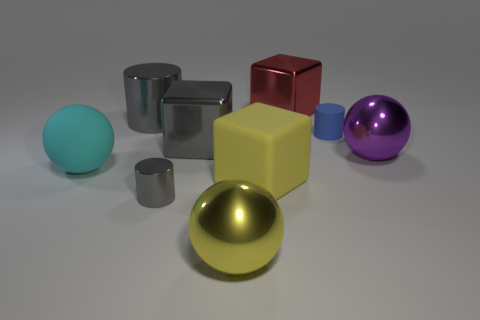Subtract all large gray metal cubes. How many cubes are left? 2 Subtract all cyan cubes. How many gray cylinders are left? 2 Subtract 1 cylinders. How many cylinders are left? 2 Subtract all cyan cylinders. Subtract all gray spheres. How many cylinders are left? 3 Subtract all cylinders. How many objects are left? 6 Subtract 0 brown spheres. How many objects are left? 9 Subtract all big purple things. Subtract all large gray metal objects. How many objects are left? 6 Add 6 gray shiny things. How many gray shiny things are left? 9 Add 3 gray shiny cylinders. How many gray shiny cylinders exist? 5 